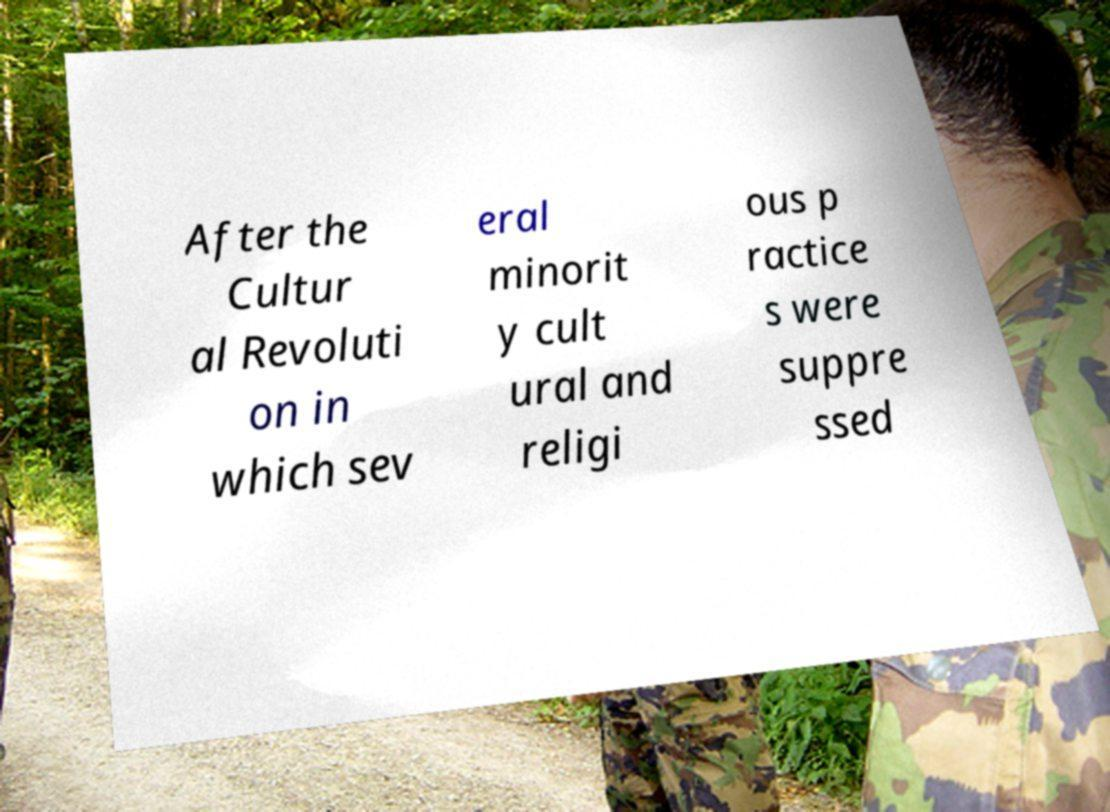I need the written content from this picture converted into text. Can you do that? After the Cultur al Revoluti on in which sev eral minorit y cult ural and religi ous p ractice s were suppre ssed 